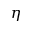Convert formula to latex. <formula><loc_0><loc_0><loc_500><loc_500>\eta</formula> 